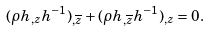Convert formula to latex. <formula><loc_0><loc_0><loc_500><loc_500>( \rho h _ { , z } h ^ { - 1 } ) _ { , \overline { z } } + ( \rho h _ { , \overline { z } } h ^ { - 1 } ) _ { , z } = 0 .</formula> 